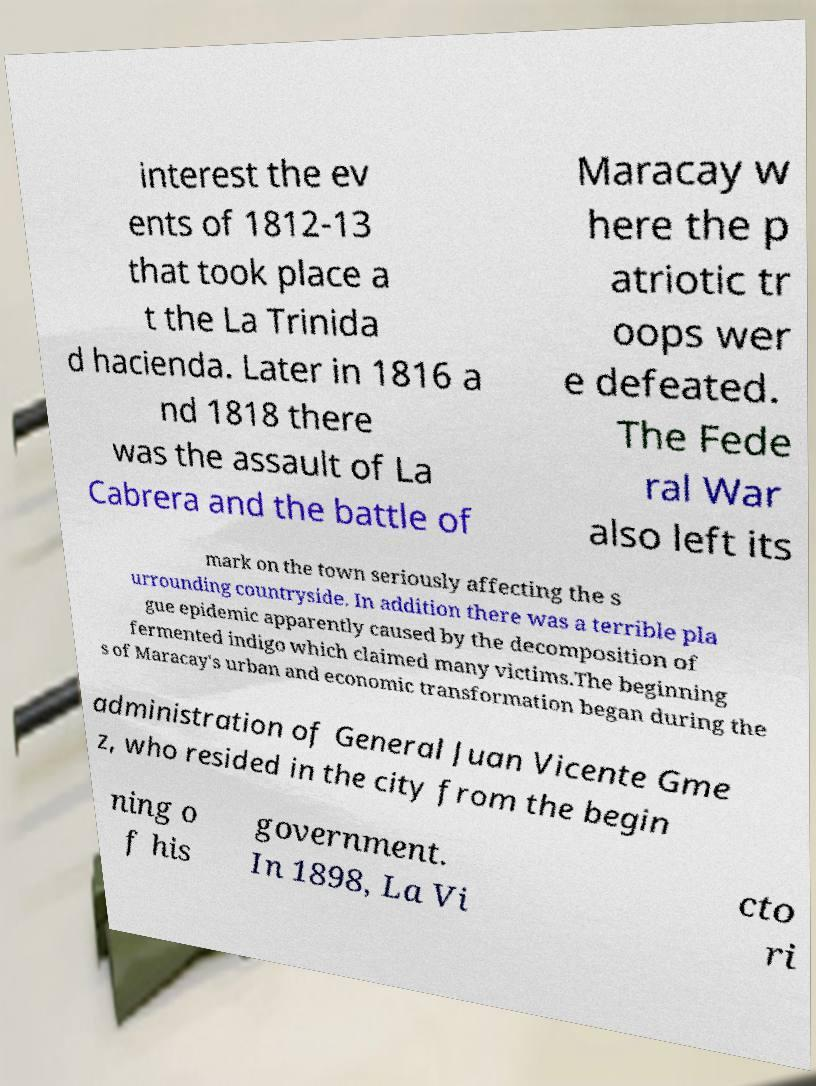Can you accurately transcribe the text from the provided image for me? interest the ev ents of 1812-13 that took place a t the La Trinida d hacienda. Later in 1816 a nd 1818 there was the assault of La Cabrera and the battle of Maracay w here the p atriotic tr oops wer e defeated. The Fede ral War also left its mark on the town seriously affecting the s urrounding countryside. In addition there was a terrible pla gue epidemic apparently caused by the decomposition of fermented indigo which claimed many victims.The beginning s of Maracay's urban and economic transformation began during the administration of General Juan Vicente Gme z, who resided in the city from the begin ning o f his government. In 1898, La Vi cto ri 